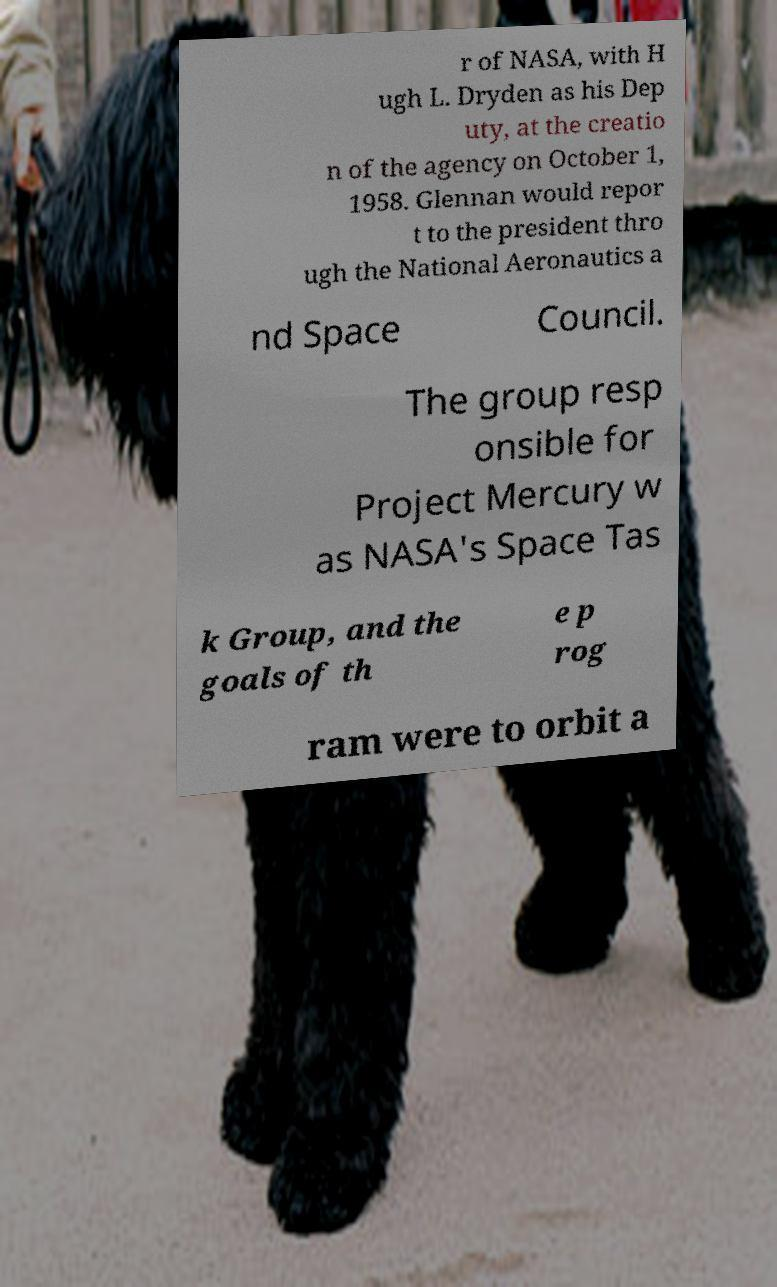I need the written content from this picture converted into text. Can you do that? r of NASA, with H ugh L. Dryden as his Dep uty, at the creatio n of the agency on October 1, 1958. Glennan would repor t to the president thro ugh the National Aeronautics a nd Space Council. The group resp onsible for Project Mercury w as NASA's Space Tas k Group, and the goals of th e p rog ram were to orbit a 